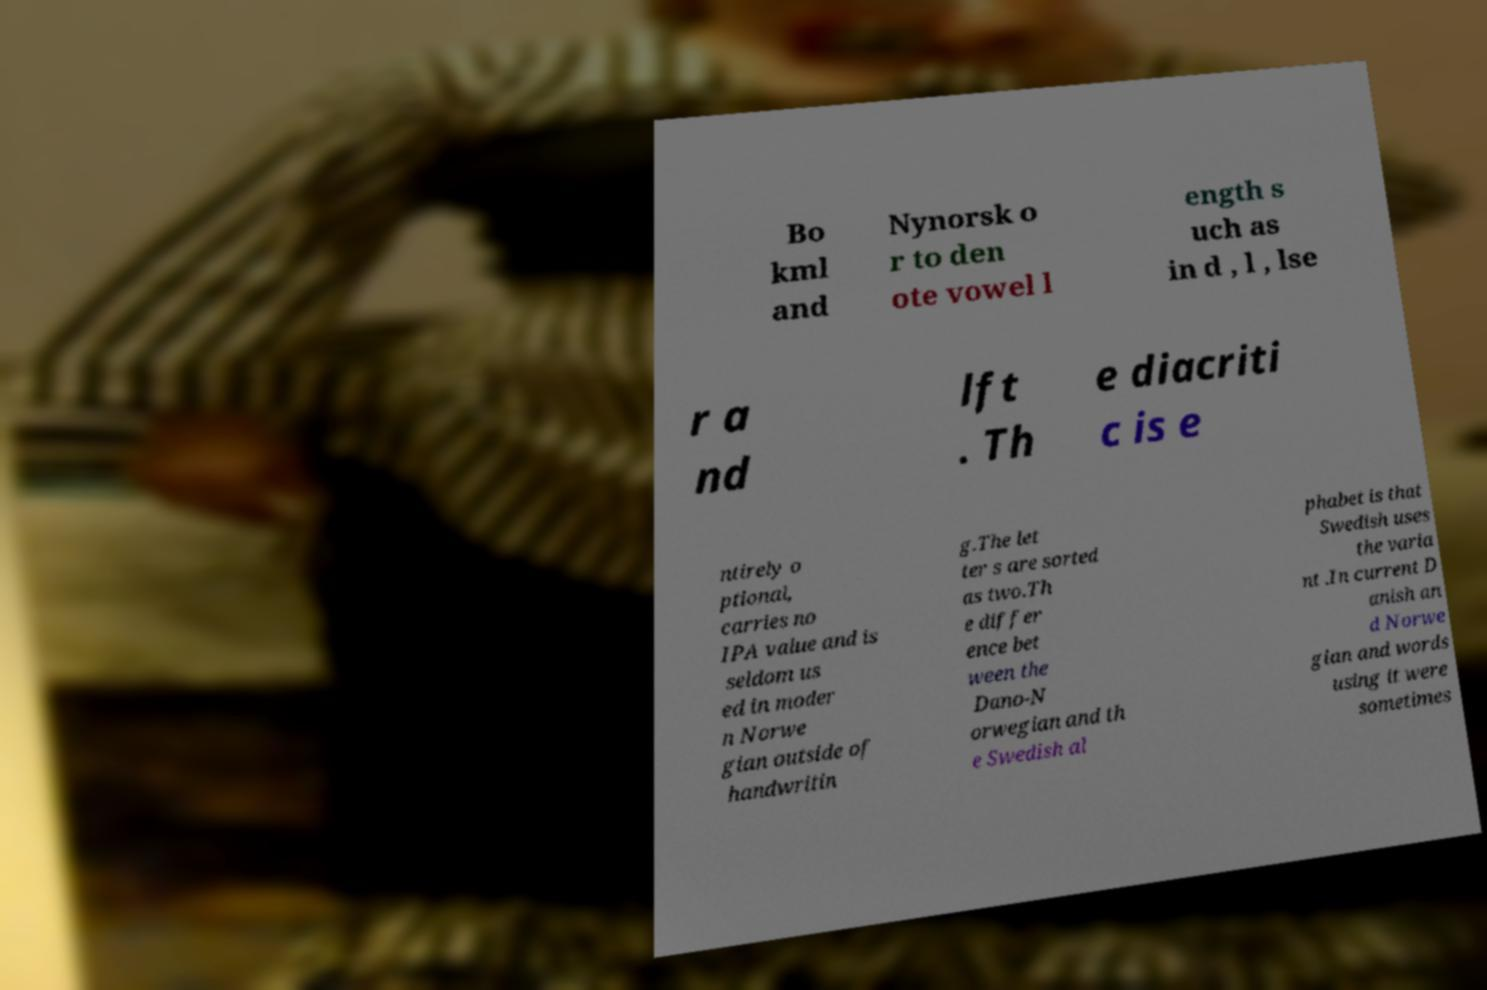Could you assist in decoding the text presented in this image and type it out clearly? Bo kml and Nynorsk o r to den ote vowel l ength s uch as in d , l , lse r a nd lft . Th e diacriti c is e ntirely o ptional, carries no IPA value and is seldom us ed in moder n Norwe gian outside of handwritin g.The let ter s are sorted as two.Th e differ ence bet ween the Dano-N orwegian and th e Swedish al phabet is that Swedish uses the varia nt .In current D anish an d Norwe gian and words using it were sometimes 